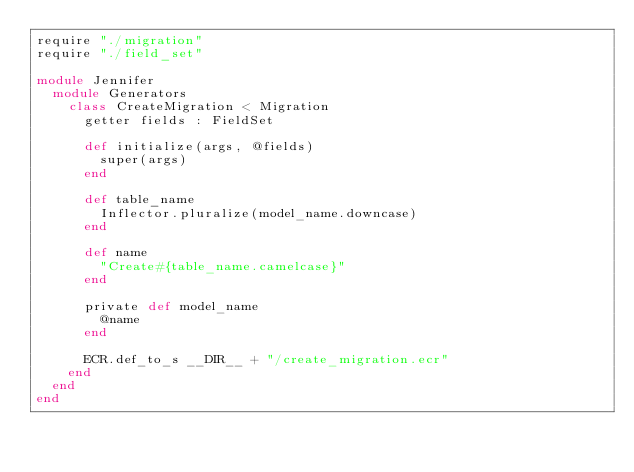<code> <loc_0><loc_0><loc_500><loc_500><_Crystal_>require "./migration"
require "./field_set"

module Jennifer
  module Generators
    class CreateMigration < Migration
      getter fields : FieldSet

      def initialize(args, @fields)
        super(args)
      end

      def table_name
        Inflector.pluralize(model_name.downcase)
      end

      def name
        "Create#{table_name.camelcase}"
      end

      private def model_name
        @name
      end

      ECR.def_to_s __DIR__ + "/create_migration.ecr"
    end
  end
end
</code> 